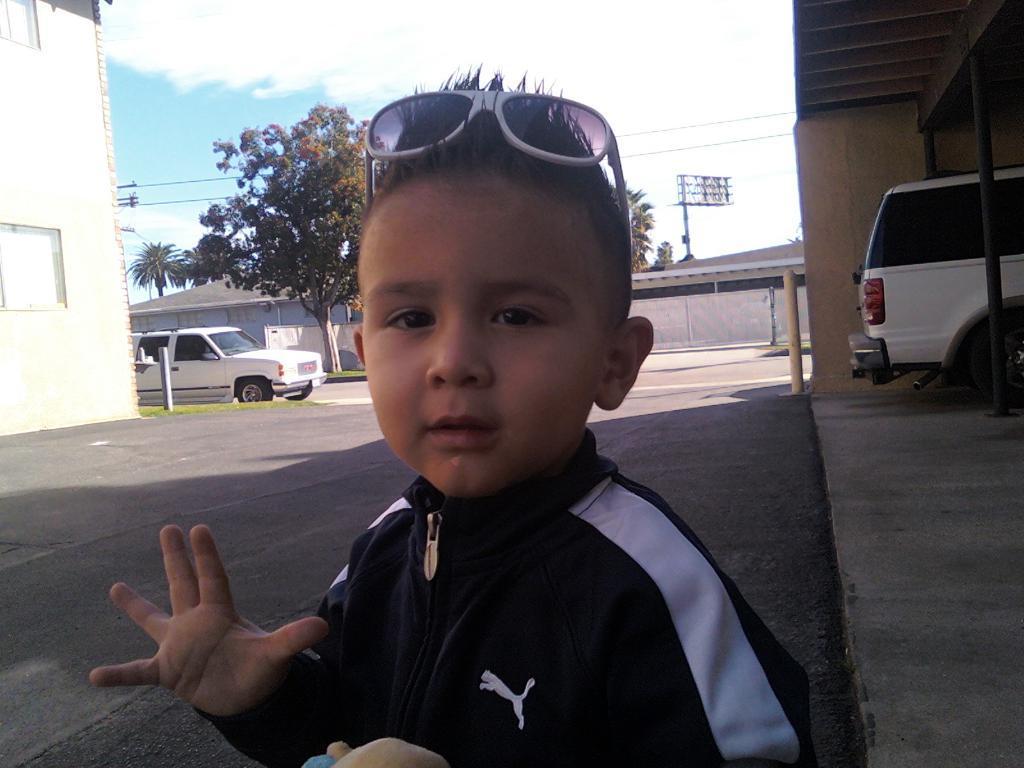Please provide a concise description of this image. In this image we can see a child, motor vehicles, trees, electric cables, sheds, building and sky with clouds. 